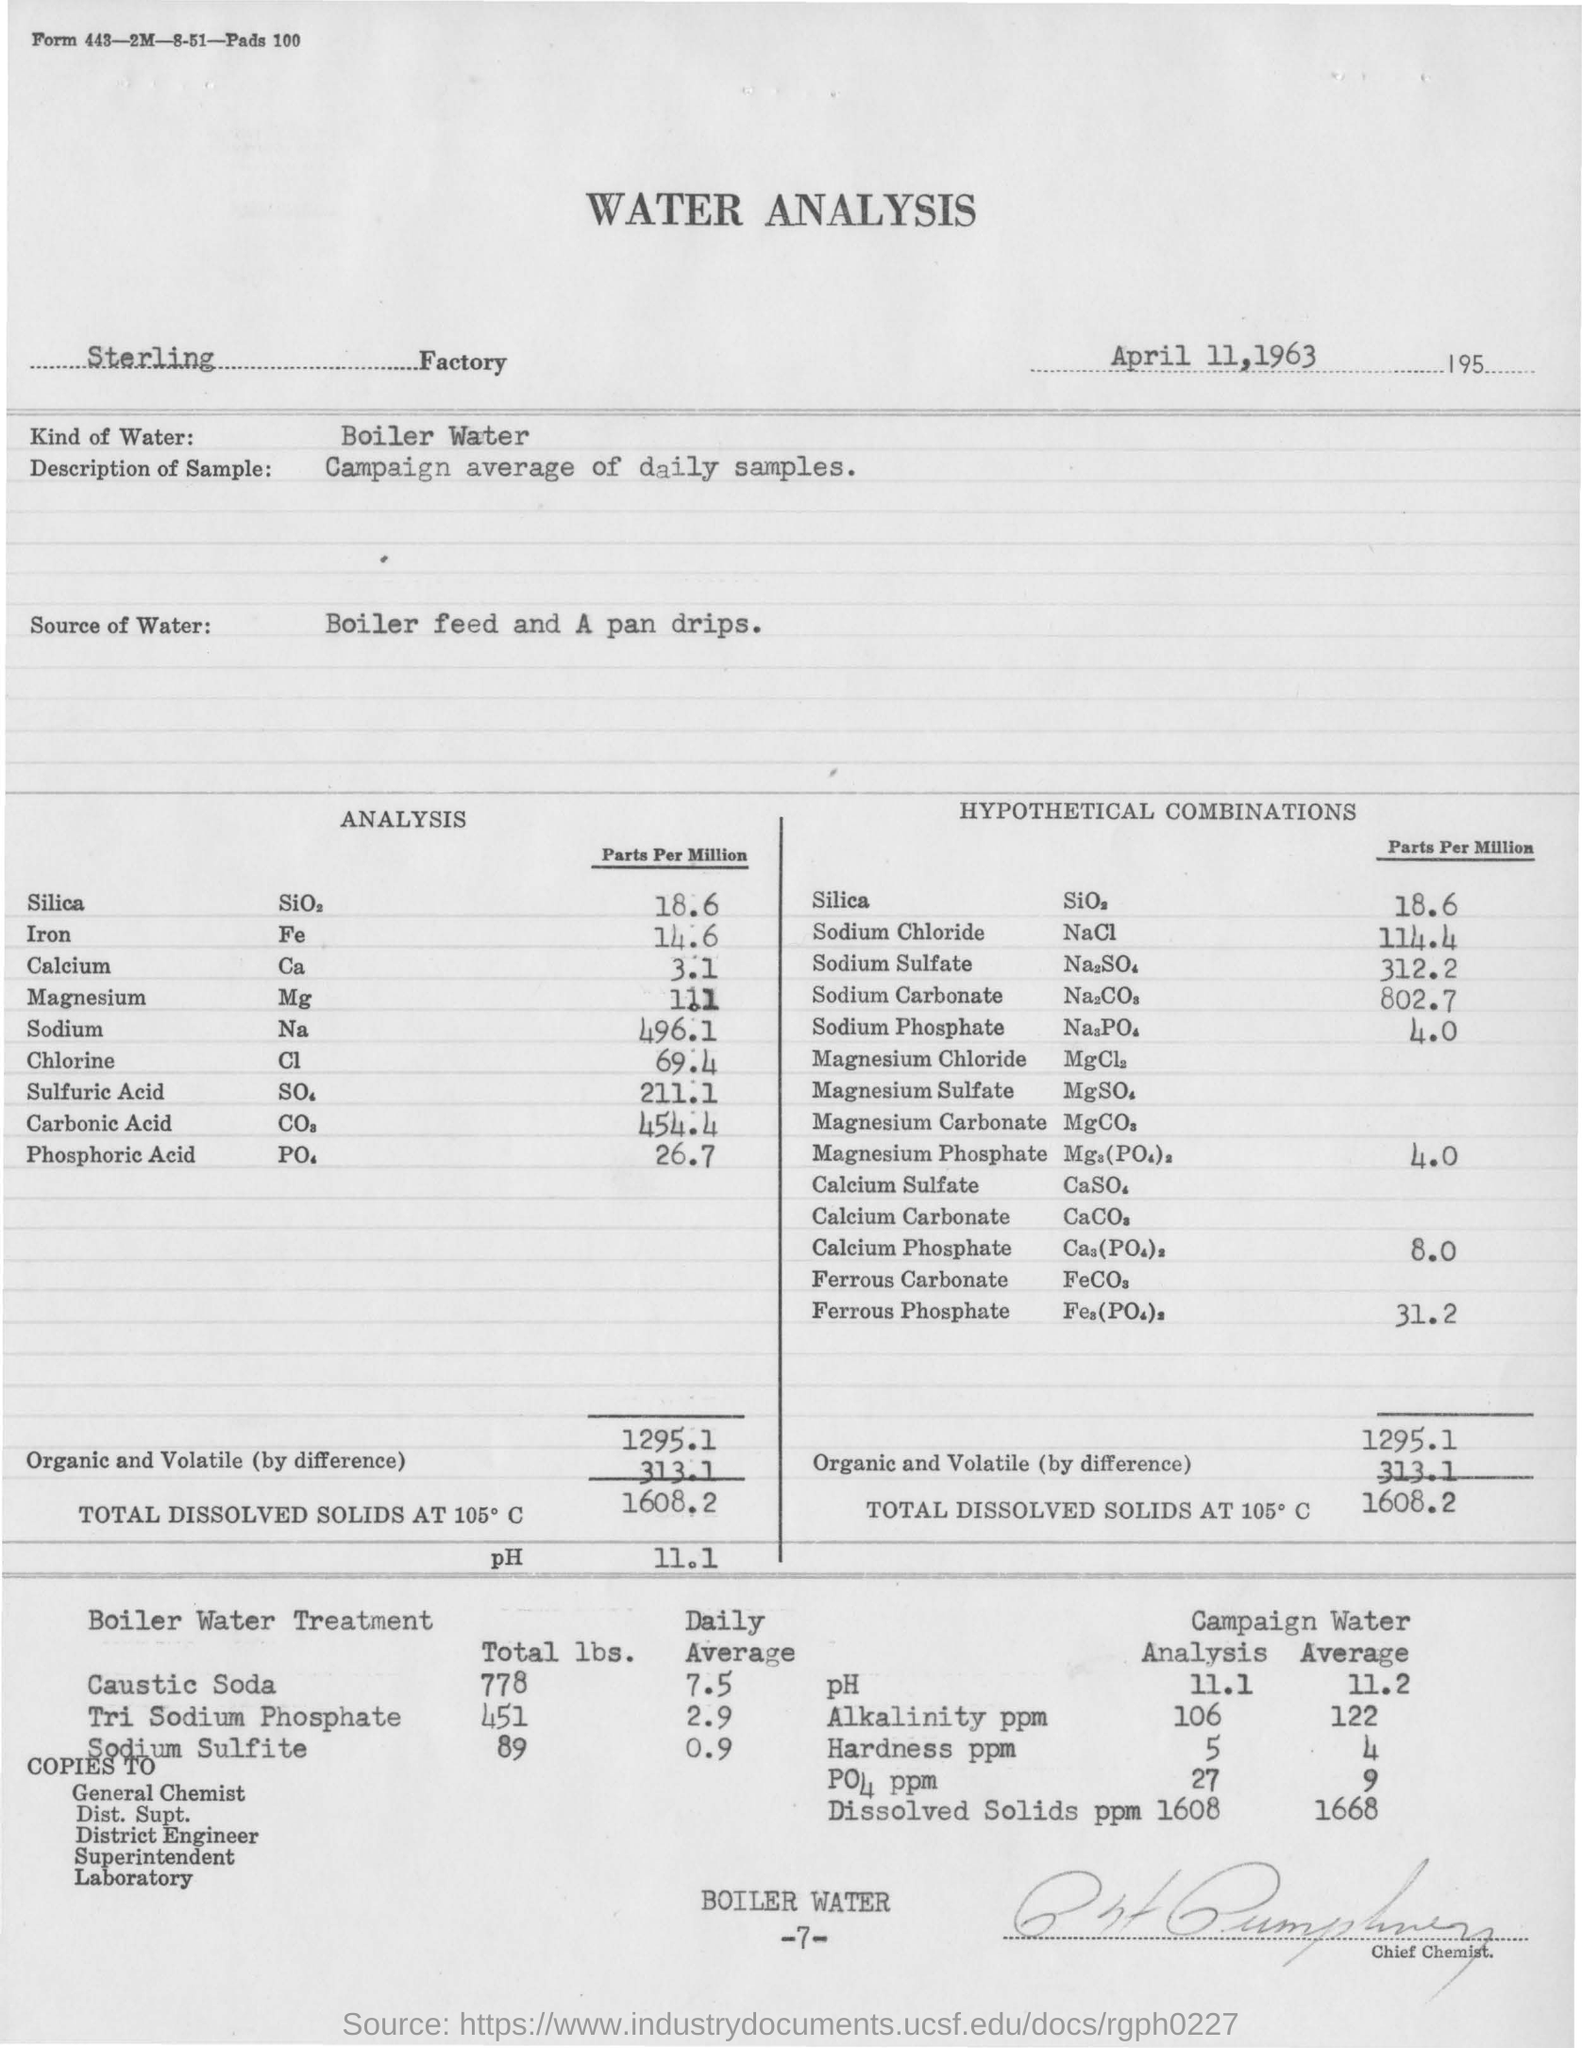Draw attention to some important aspects in this diagram. It is important to use appropriate types of water for analysis, such as boiler water, as this can affect the accuracy of the results. The volume of Calcium (parts per million) in the sample is 3.1. The sample taken is described as having a specific characteristic, and the average daily samples for the campaign are reported. The document mentions analysis related to water. The volume of Silica (Parts per Million) in the sample is 18.6... 